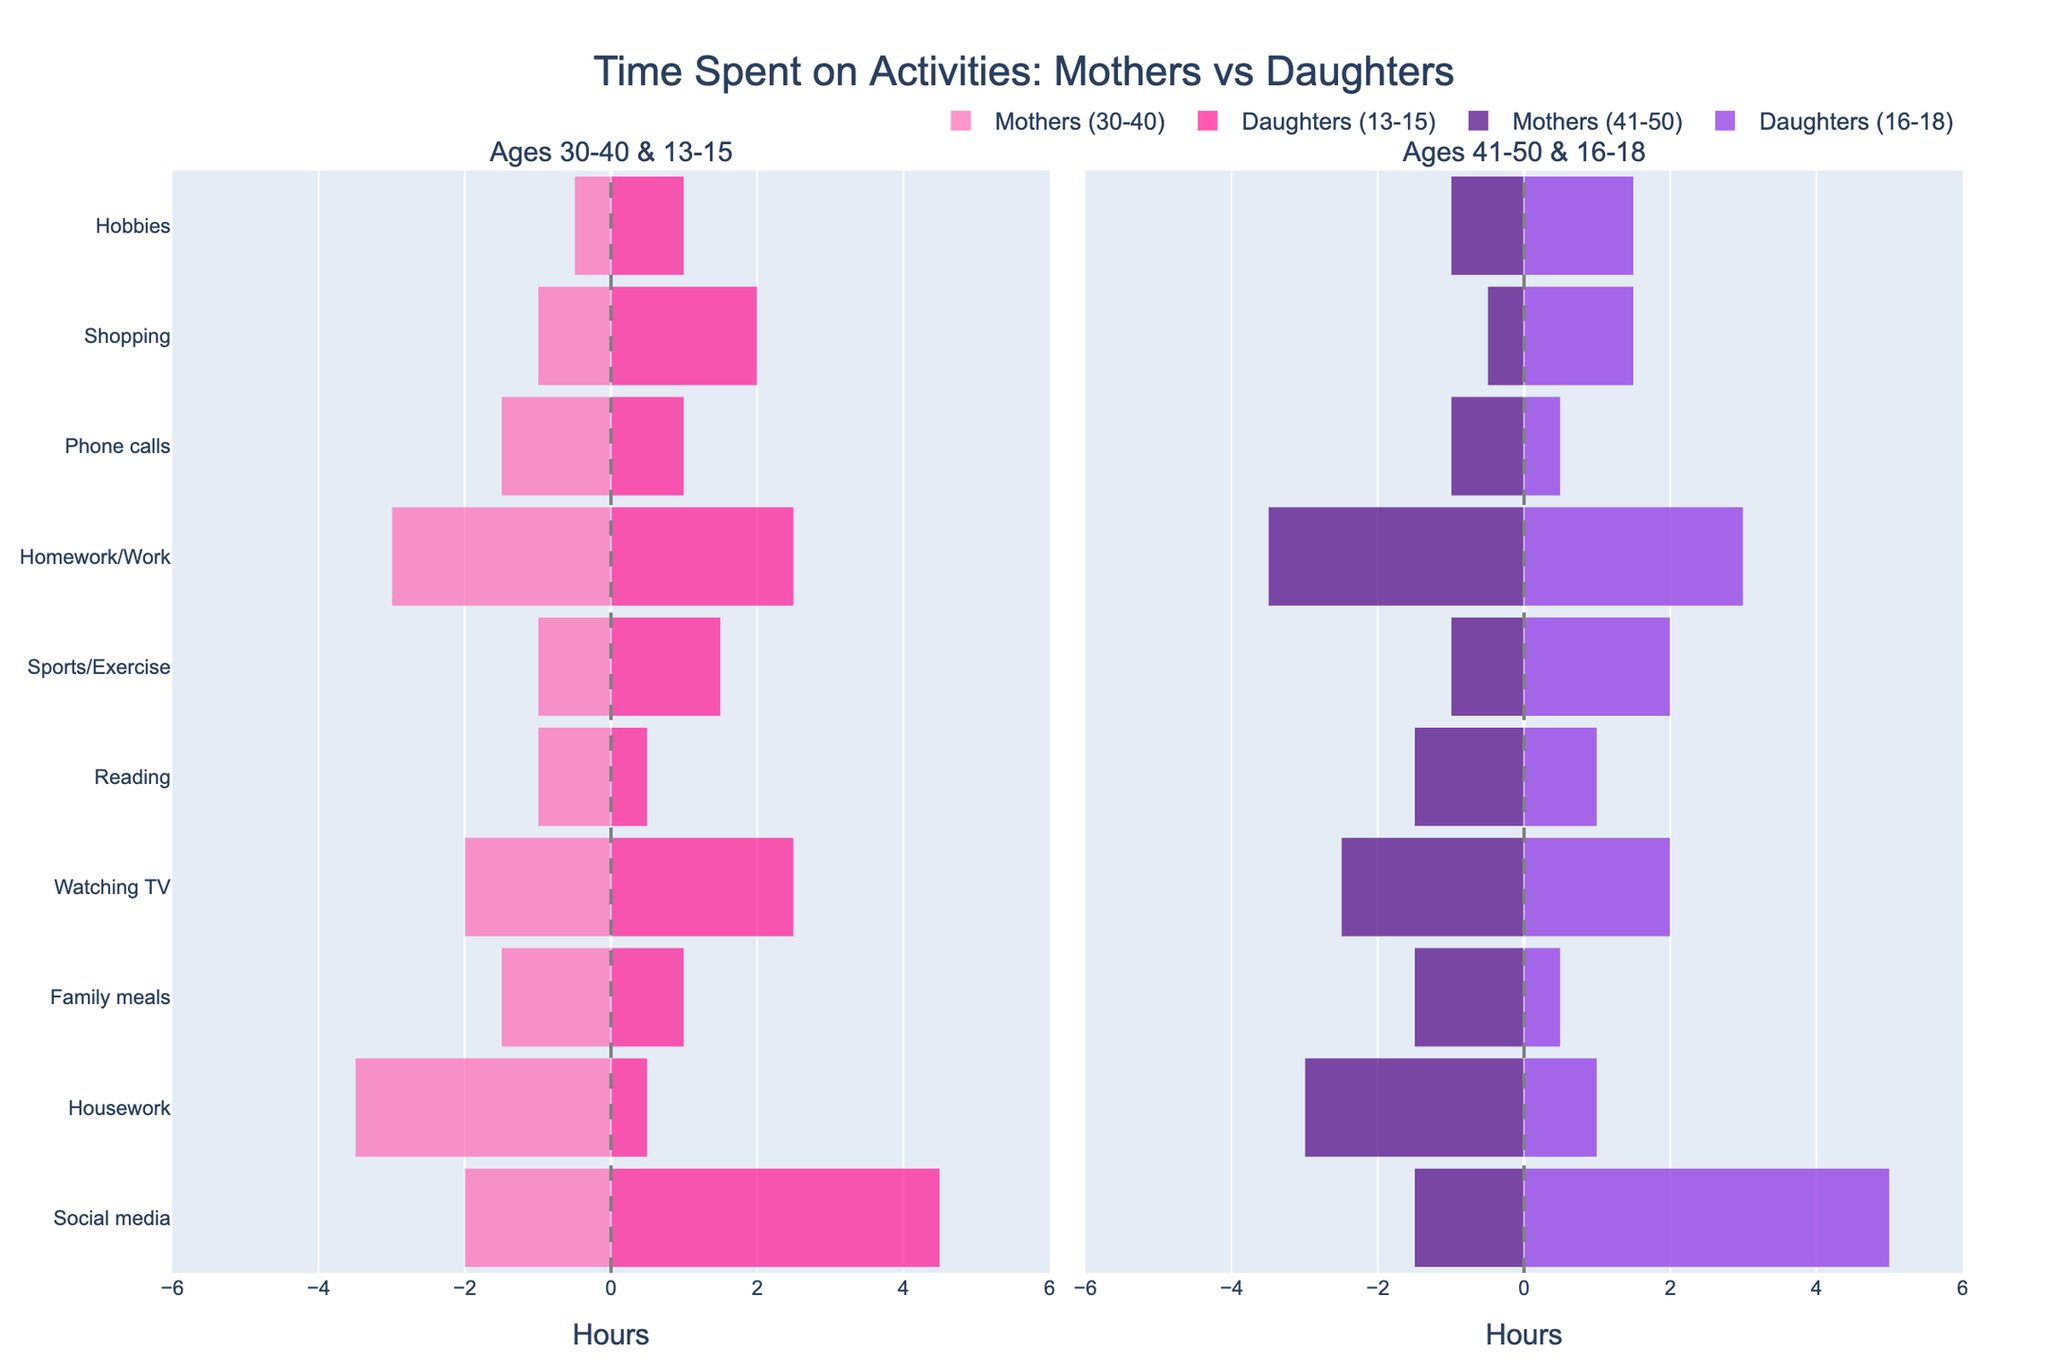What is the title of the figure? The title is located at the top of the figure and provides a summary of what the figure represents.
Answer: Time Spent on Activities: Mothers vs Daughters Which activity do mothers aged 30-40 spend the most time on? Look at the bar segment representing 'Mothers (30-40)' with the largest absolute negative value.
Answer: Housework How many hours do daughters aged 16-18 spend on social media? Find the 'Social media' activity on the y-axis and look at the corresponding bar segment for 'Daughters (16-18)', shown in the second subplot.
Answer: 5 Do mothers or daughters aged 13-15 spend more time on homework/work? Compare the bar lengths for the 'Homework/Work' activity in the first subplot for both 'Mothers (30-40)' and 'Daughters (13-15)'.
Answer: Mothers What is the combined time spent on reading and sports/exercise for daughters aged 13-15? Sum the hours for 'Reading' and 'Sports/Exercise' for 'Daughters (13-15)' from the first subplot. Reading = 0.5, Sports/Exercise = 1.5; 0.5 + 1.5 = 2
Answer: 2 Which age group (mothers 30-40, mothers 41-50, daughters 13-15, daughters 16-18) spends the least time on family meals? Compare the bar lengths for the 'Family meals' activity across all four groups.
Answer: Daughters (16-18) What is the difference in hours spent on phone calls between mothers aged 41-50 and their daughters aged 16-18? Subtract the hours for 'Phone calls' for 'Daughters (16-18)' from 'Mothers (41-50)' in the second subplot. Mothers (41-50) = 1, Daughters (16-18) = 0.5; 1 - 0.5 = 0.5
Answer: 0.5 How does the time spent shopping differ between mothers aged 30-40 and daughters aged 13-15? Compare the bar lengths for the 'Shopping' activity in the first subplot for 'Mothers (30-40)' and 'Daughters (13-15)'.
Answer: Daughters spend 1 more hour What activity do daughters aged 16-18 spend less time on compared to daughters aged 13-15? Identify activities where the 'Daughters (16-18)' bar segment is shorter than the 'Daughters (13-15)' segment.
Answer: Family meals, Phone calls What activity shows a reversed trend, where mothers aged 41-50 spend more time than those aged 30-40? Compare the bar lengths between 'Mothers (30-40)' and 'Mothers (41-50)' for all activities and find where the second group spends more time.
Answer: Reading 